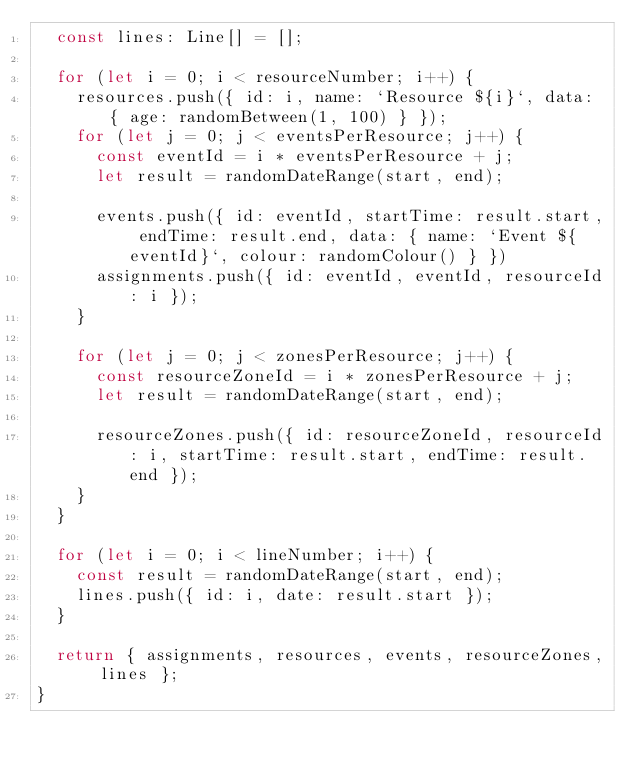<code> <loc_0><loc_0><loc_500><loc_500><_TypeScript_>  const lines: Line[] = [];

  for (let i = 0; i < resourceNumber; i++) {
    resources.push({ id: i, name: `Resource ${i}`, data: { age: randomBetween(1, 100) } });
    for (let j = 0; j < eventsPerResource; j++) {
      const eventId = i * eventsPerResource + j;
      let result = randomDateRange(start, end);

      events.push({ id: eventId, startTime: result.start, endTime: result.end, data: { name: `Event ${eventId}`, colour: randomColour() } })
      assignments.push({ id: eventId, eventId, resourceId: i });
    }

    for (let j = 0; j < zonesPerResource; j++) {
      const resourceZoneId = i * zonesPerResource + j;
      let result = randomDateRange(start, end);

      resourceZones.push({ id: resourceZoneId, resourceId: i, startTime: result.start, endTime: result.end });
    }
  }

  for (let i = 0; i < lineNumber; i++) {
    const result = randomDateRange(start, end);
    lines.push({ id: i, date: result.start });
  }

  return { assignments, resources, events, resourceZones, lines };
}</code> 